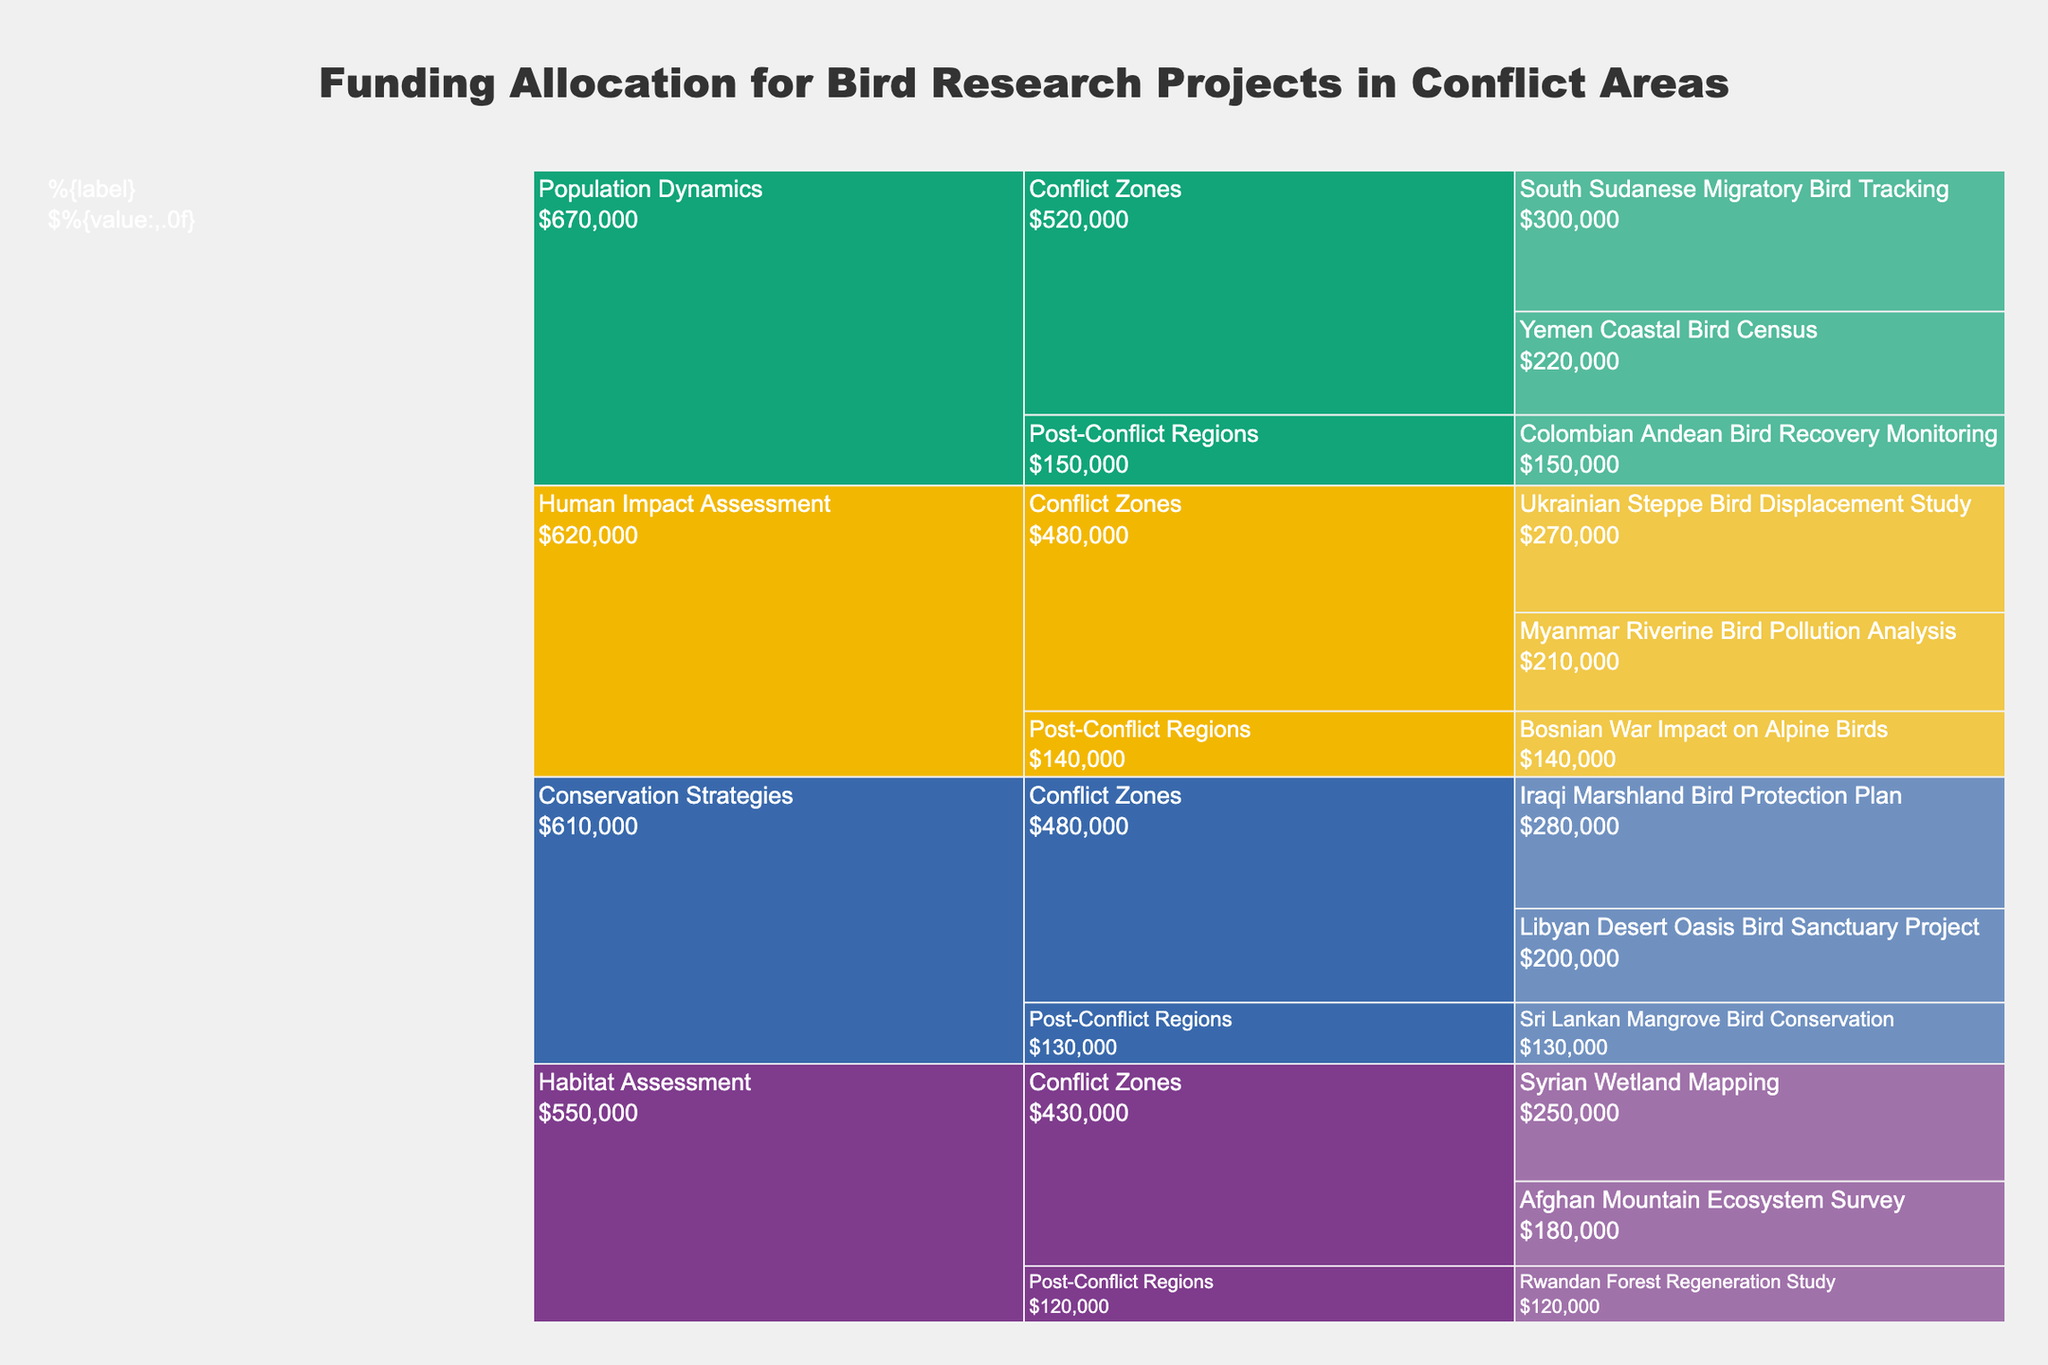Which research objective has the highest total funding allocation? Sum the funding allocations for each research objective and compare. The total funding for "Population Dynamics" is $670,000, for "Conservation Strategies" is $610,000, for "Human Impact Assessment" is $620,000, and for "Habitat Assessment" is $550,000. Therefore, "Population Dynamics" has the highest total funding allocation.
Answer: Population Dynamics How much total funding is allocated for projects in post-conflict regions? Sum the allocations for all projects in post-conflict regions. ($120,000 + $150,000 + $130,000 + $140,000)
Answer: $540,000 Which project within "Conservation Strategies" has received the least funding? Compare the funding allocations within the "Conservation Strategies" objective: Iraqi Marshland Bird Protection Plan ($280,000), Libyan Desert Oasis Bird Sanctuary Project ($200,000), Sri Lankan Mangrove Bird Conservation ($130,000). The least funded project is "Sri Lankan Mangrove Bird Conservation".
Answer: Sri Lankan Mangrove Bird Conservation What is the total funding allocated for projects in conflict zones under "Human Impact Assessment"? Sum the allocations for "Human Impact Assessment" projects in conflict zones: ($270,000 + $210,000)
Answer: $480,000 How does the total allocation for "Habitat Assessment" projects in conflict zones compare to those in post-conflict regions? Sum the allocations for "Habitat Assessment" projects in conflict zones ($250,000 + $180,000 = $430,000) and post-conflict regions ($120,000). Compare the totals: $430,000 (conflict zones) is greater than $120,000 (post-conflict regions).
Answer: $430,000 is greater than $120,000 Which specific project has the highest funding allocation and how much is allocated to it? Compare all the individual project allocations and identify the highest one. "South Sudanese Migratory Bird Tracking" under "Population Dynamics" in conflict zones has the highest funding allocation at $300,000.
Answer: South Sudanese Migratory Bird Tracking - $300,000 What's the average funding allocation for projects under "Population Dynamics"? Calculate the average funding for "Population Dynamics": (300,000 + 220,000 + 150,000)/3 = $670,000/3
Answer: $223,333 How many projects focus on "Conservation Strategies"? Count the number of projects under the "Conservation Strategies" objective. There are three projects in total: Iraqi Marshland Bird Protection Plan, Libyan Desert Oasis Bird Sanctuary Project, and Sri Lankan Mangrove Bird Conservation.
Answer: 3 Which funding area has the most diverse set of research objectives represented? Compare the number of different research objectives represented in conflict zones and post-conflict regions. Conflict zones have 4 objectives (Habitat Assessment, Population Dynamics, Conservation Strategies, Human Impact Assessment), and post-conflict regions have 3 objectives (Habitat Assessment, Population Dynamics, Conservation Strategies). Conflict zones have the most diverse set of research objectives.
Answer: Conflict Zones What proportion of the total funding is allocated to "Human Impact Assessment" compared to the overall funding? Sum total funding: ($2,400,000). Sum funding for "Human Impact Assessment": ($620,000). Calculate the proportion: $620,000 / $2,400,000 = 0.2583 or 25.83%
Answer: 25.83% 